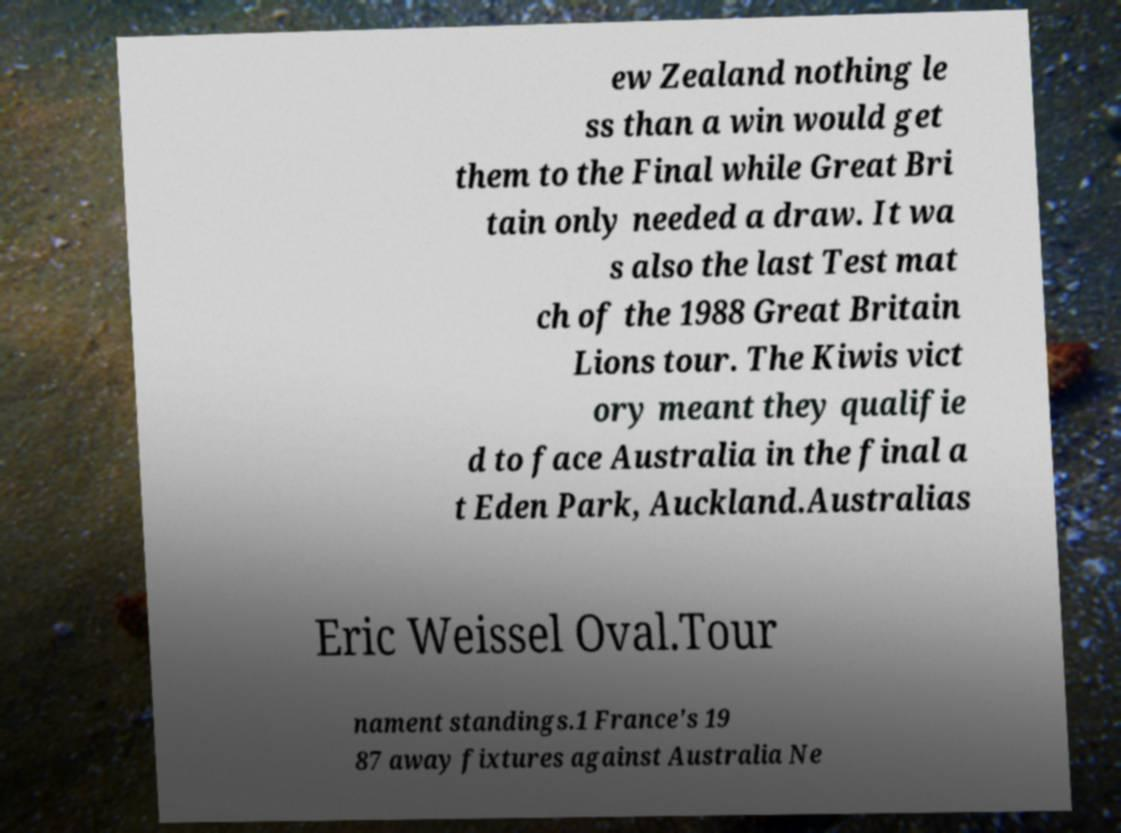Could you assist in decoding the text presented in this image and type it out clearly? ew Zealand nothing le ss than a win would get them to the Final while Great Bri tain only needed a draw. It wa s also the last Test mat ch of the 1988 Great Britain Lions tour. The Kiwis vict ory meant they qualifie d to face Australia in the final a t Eden Park, Auckland.Australias Eric Weissel Oval.Tour nament standings.1 France's 19 87 away fixtures against Australia Ne 